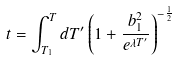<formula> <loc_0><loc_0><loc_500><loc_500>t = \int _ { T _ { 1 } } ^ { T } d T ^ { \prime } \left ( 1 + \frac { b _ { 1 } ^ { 2 } } { e ^ { \lambda T ^ { \prime } } } \right ) ^ { - \frac { 1 } { 2 } }</formula> 